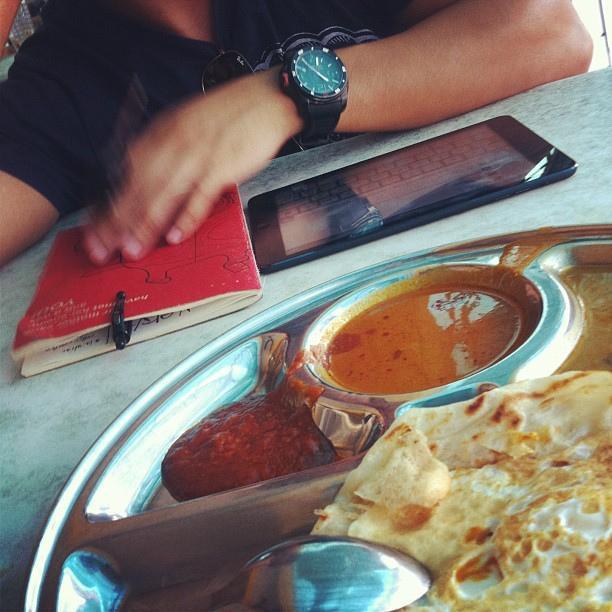How many zebras are running?
Give a very brief answer. 0. 